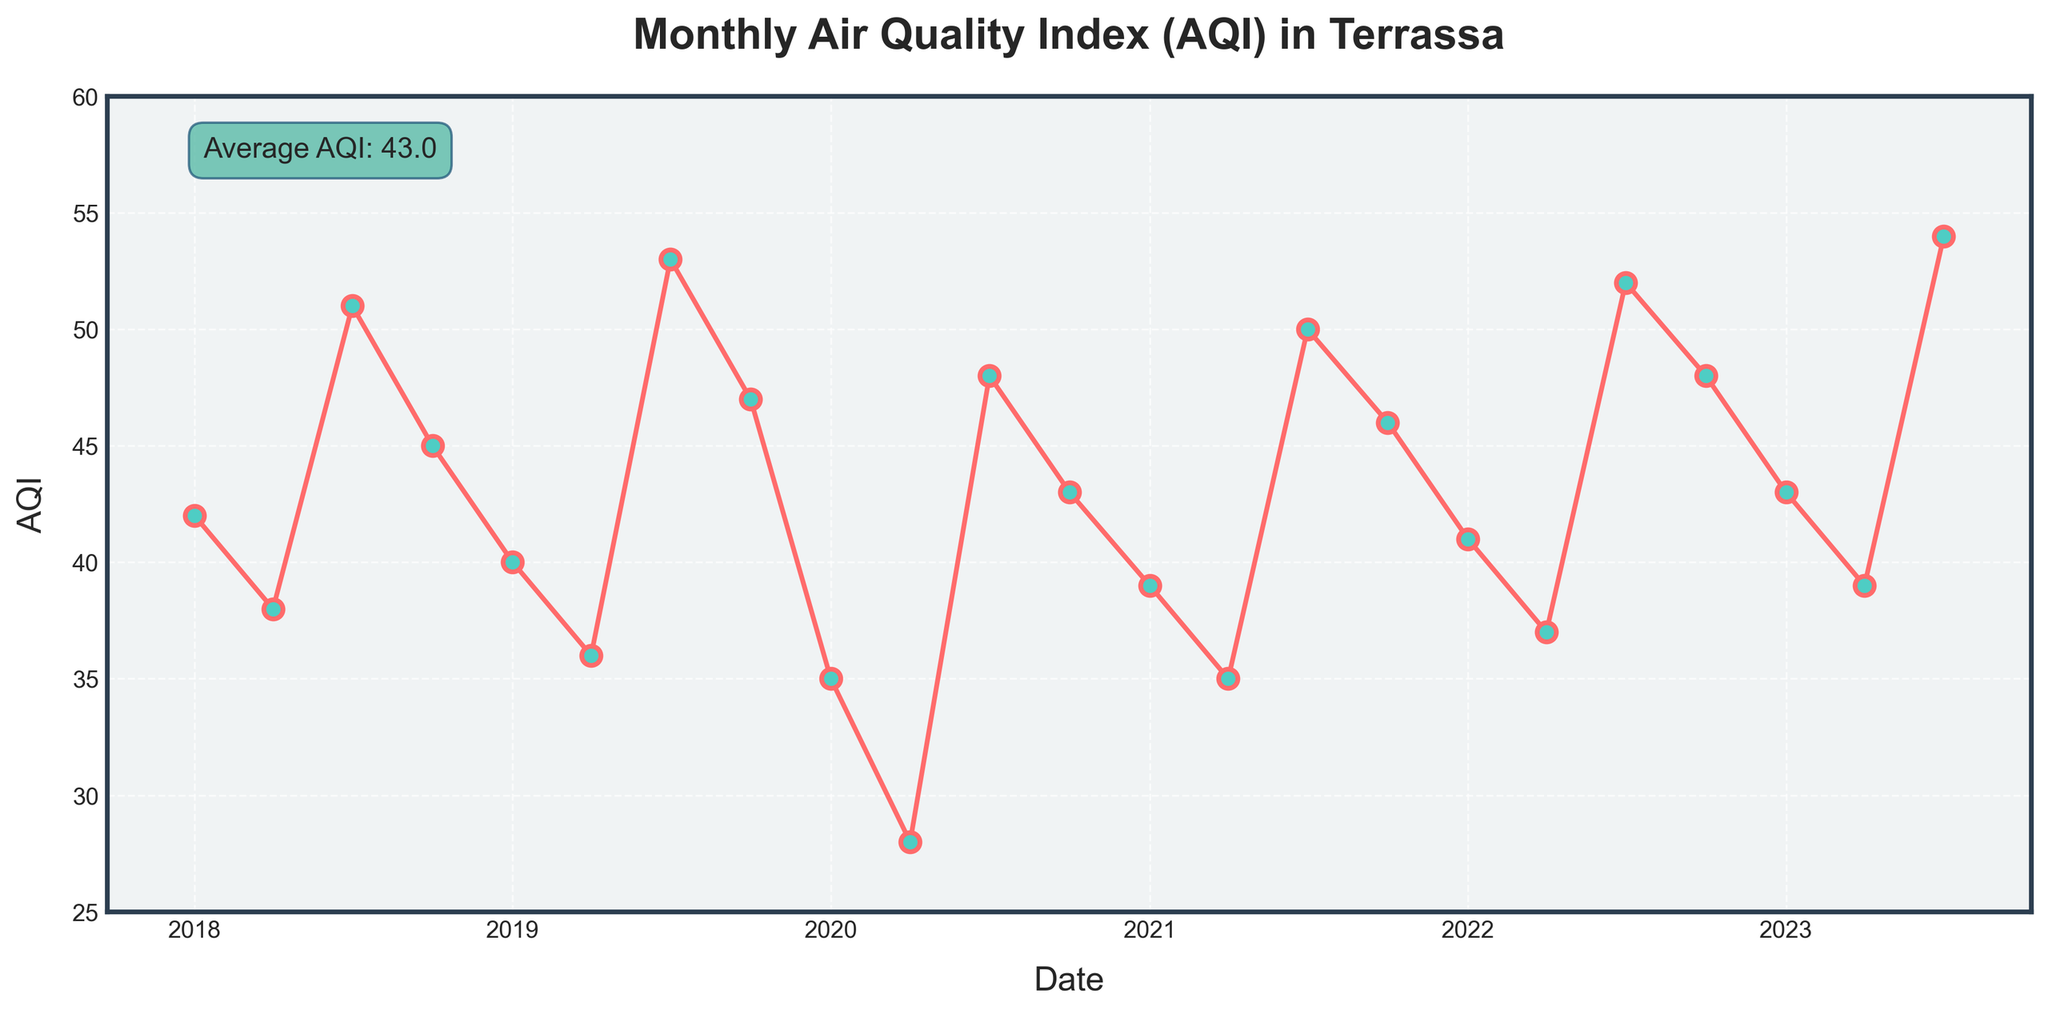what's the highest AQI level within the last 5 years? First, observe the line chart to identify the data point with the highest value. The highest AQI level can be seen as the peak on the graph.
Answer: 54 How does the AQI in July 2020 compare to April 2020? Check the AQI levels for both dates on the line chart. July 2020 has an AQI of 48 while April 2020 has an AQI of 28. Thus, July 2020's AQI is higher.
Answer: July 2020's AQI is higher What is the average AQI over the 5-year period? The average AQI is given as a text annotation on the line chart. The average value displayed is around 42.7.
Answer: 42.7 Was there a significant change in AQI after the first quarter of 2020? Look at the AQI levels before and after April 2020. The AQI in January 2020 was 35, and it significantly dropped to 28 in April 2020. Post-April 2020, the AQI rose to 48 in July and 43 in October.
Answer: Yes, there was a significant drop in April 2020, followed by a rise What's the AQI trend in every July over these 5 years? Extract AQI values for Julys: 2018 (51), 2019 (53), 2020 (48), 2021 (50), 2022 (52), 2023 (54). The trend seems to oscillate slightly but generally rises.
Answer: Increasing trend Which month and year had the lowest AQI? Identify the lowest point on the line chart. The lowest AQI is noted in April 2020, where the AQI is 28.
Answer: April 2020 Compare the average AQI of all Octobers to that of all Aprils. Octobers: 2018 (45), 2019 (47), 2020 (43), 2021 (46), 2022 (48) -> average (45.8). Aprils: 2018 (38), 2019 (36), 2020 (28), 2021 (35), 2022 (37), 2023 (39) -> average (35.5). Octobers have a higher average AQI.
Answer: Octobers have a higher average AQI What color and shape are the markers representing the AQI data points on the plot? The markers are circular (o) in shape, have a turquoise (light greenish) color filling, and a red outline.
Answer: Circular, turquoise filling, red outline Is the AQI trend from January 2018 to January 2023 increasing or decreasing? Observe the line from January 2018 to January 2023. The AQI in January 2018 is 42 and in January 2023 is 43, indicating an overall slight increasing trend.
Answer: Slightly increasing 